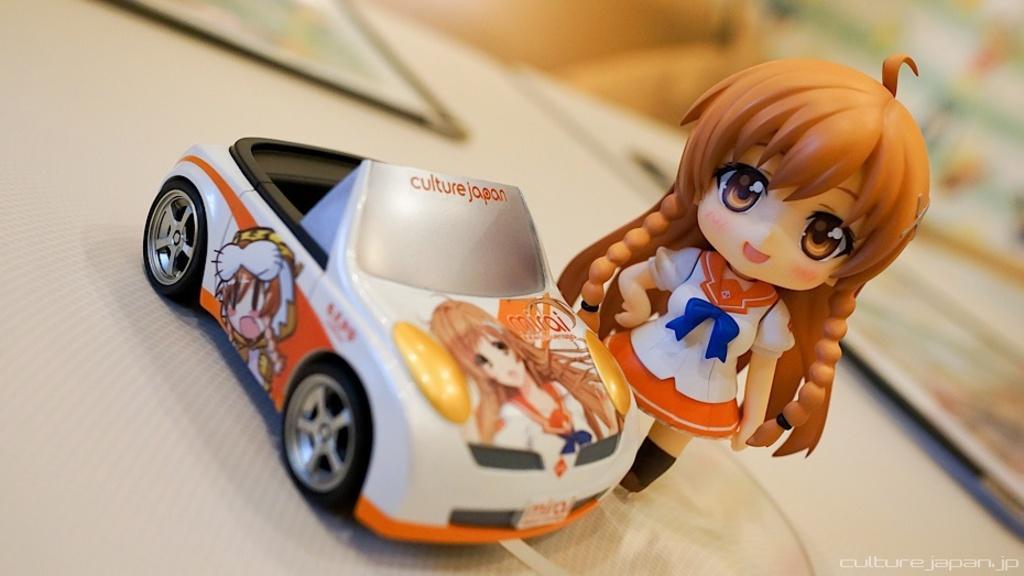Can you describe this image briefly? In this image we can see a woman doll and a car toy placed on a table. 